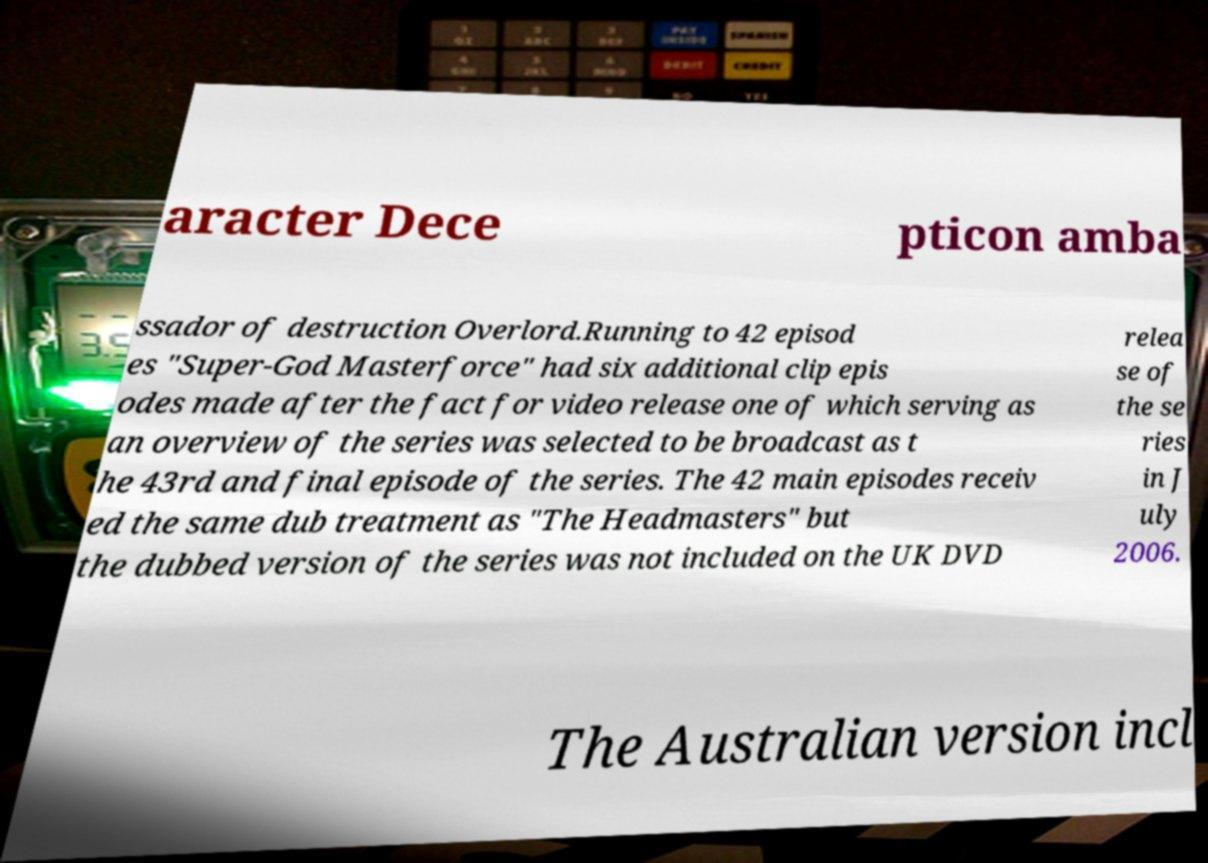Please identify and transcribe the text found in this image. aracter Dece pticon amba ssador of destruction Overlord.Running to 42 episod es "Super-God Masterforce" had six additional clip epis odes made after the fact for video release one of which serving as an overview of the series was selected to be broadcast as t he 43rd and final episode of the series. The 42 main episodes receiv ed the same dub treatment as "The Headmasters" but the dubbed version of the series was not included on the UK DVD relea se of the se ries in J uly 2006. The Australian version incl 